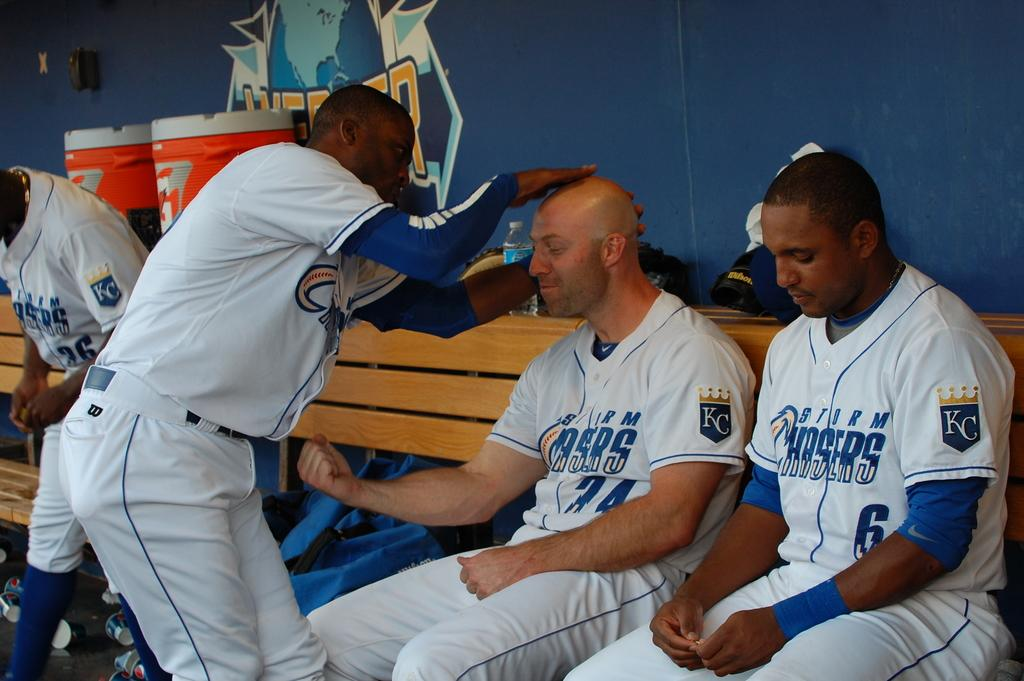Provide a one-sentence caption for the provided image. Two baseball players sitting in a dugout and another player patting one on the head. 